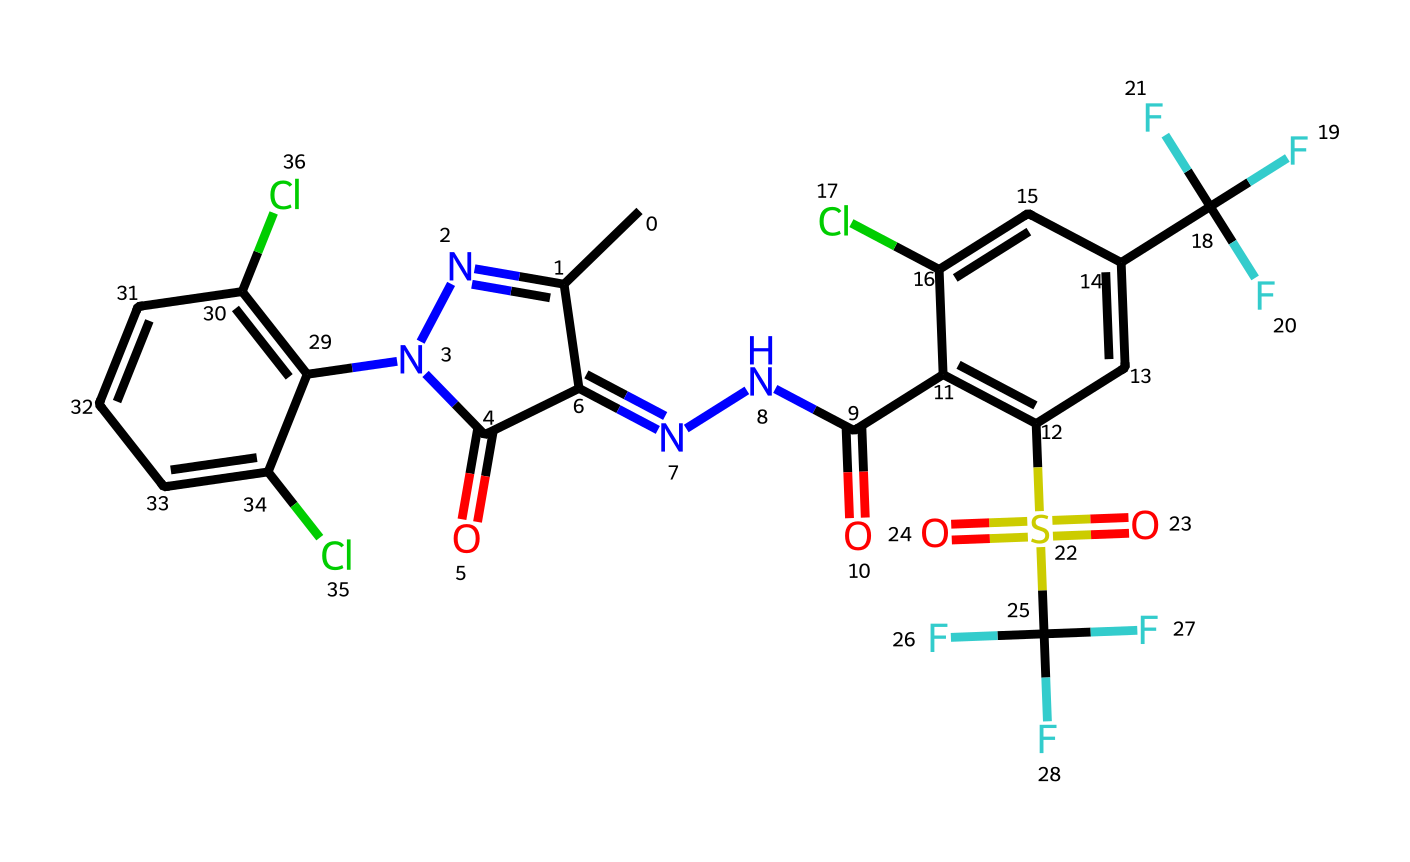What is the main active ingredient in this pesticide? The chemical structure represents fipronil, which is a well-known insecticide used in pest control. The arrangement of atoms and specific functional groups point to its identity.
Answer: fipronil How many chlorine atoms are present in this molecule? By examining the chemical structure, there are three chlorine atoms attached to the aromatic rings, indicated by the "Cl" in the SMILES representation.
Answer: three What functional groups are present in fipronil? The SMILES reveals several functional groups, notably two imine groups (C=NC), a sulfonyl group (S(=O)(=O)), and fluorinated groups (C(F)(F)F). Identifying these groups helps in understanding its reactivity and toxicity.
Answer: imine, sulfonyl, fluorinated How many total nitrogen atoms are found in this chemical? The structure contains four nitrogen atoms. Each nitrogen can be identified within the rings and branches of the compound in the SMILES description. Counting them yields a total of four.
Answer: four What is the significance of the sulfonyl group in this pesticide? The sulfonyl group contributes to fipronil's toxicity and stability. It enhances binding to target sites in insects leading to effective pest control. Its presence is crucial for function.
Answer: toxicity and stability What type of substitution pattern is observed in the aromatic rings of fipronil? The aromatic rings in the structure exhibit a disubstitution pattern, with various groups including chlorines and a trifluoromethyl group attached to the rings, leading to enhanced insecticidal properties.
Answer: disubstitution pattern 